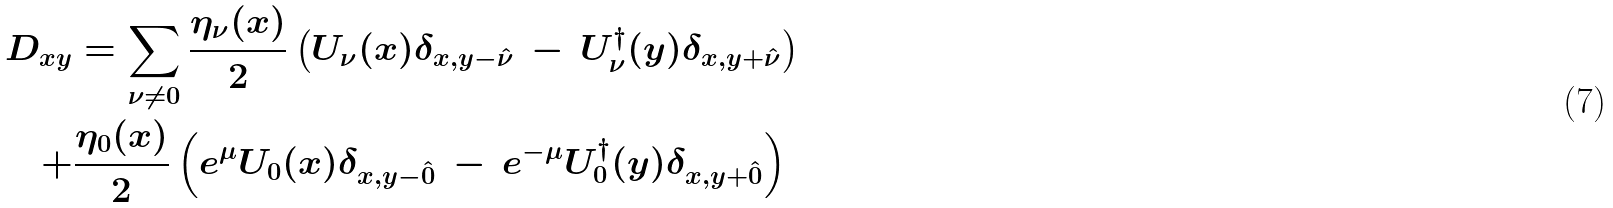Convert formula to latex. <formula><loc_0><loc_0><loc_500><loc_500>D _ { x y } & = \sum _ { \nu \not = 0 } \frac { \eta _ { \nu } ( x ) } { 2 } \left ( U _ { \nu } ( x ) \delta _ { x , y - \hat { \nu } } \, - \, U _ { \nu } ^ { \dagger } ( y ) \delta _ { x , y + \hat { \nu } } \right ) \\ + & \frac { \eta _ { 0 } ( x ) } { 2 } \left ( e ^ { \mu } U _ { 0 } ( x ) \delta _ { x , y - \hat { 0 } } \, - \, e ^ { - \mu } U _ { 0 } ^ { \dagger } ( y ) \delta _ { x , y + \hat { 0 } } \right )</formula> 